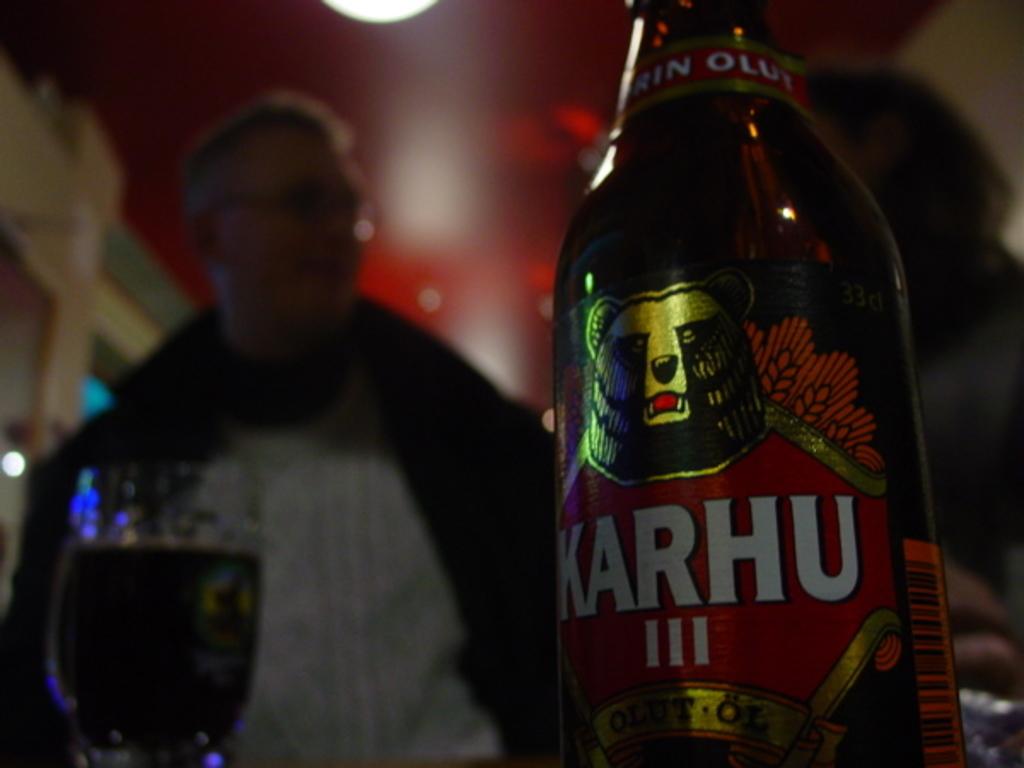What is the name of the beer?
Offer a terse response. Karhu. 